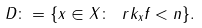<formula> <loc_0><loc_0><loc_500><loc_500>D \colon = \{ x \in X \colon \ r k _ { x } f < n \} .</formula> 